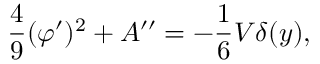<formula> <loc_0><loc_0><loc_500><loc_500>\frac { 4 } { 9 } ( \varphi ^ { \prime } ) ^ { 2 } + A ^ { \prime \prime } = - \frac { 1 } { 6 } V \delta ( y ) ,</formula> 